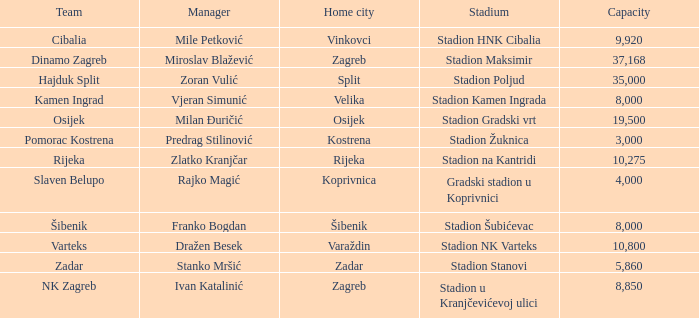What team has a home city of Velika? Kamen Ingrad. 